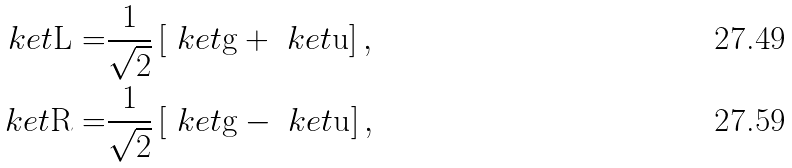Convert formula to latex. <formula><loc_0><loc_0><loc_500><loc_500>\ k e t { \text {L} } = & \frac { 1 } { \sqrt { 2 } } \left [ \ k e t { \text {g} } + \ k e t { \text {u} } \right ] , \\ \ k e t { \text {R} } = & \frac { 1 } { \sqrt { 2 } } \left [ \ k e t { \text {g} } - \ k e t { \text {u} } \right ] ,</formula> 